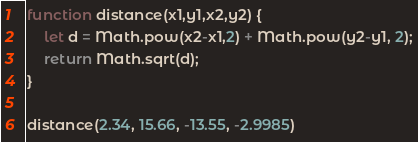Convert code to text. <code><loc_0><loc_0><loc_500><loc_500><_JavaScript_>function distance(x1,y1,x2,y2) {
    let d = Math.pow(x2-x1,2) + Math.pow(y2-y1, 2);
    return Math.sqrt(d);
}

distance(2.34, 15.66, -13.55, -2.9985)</code> 